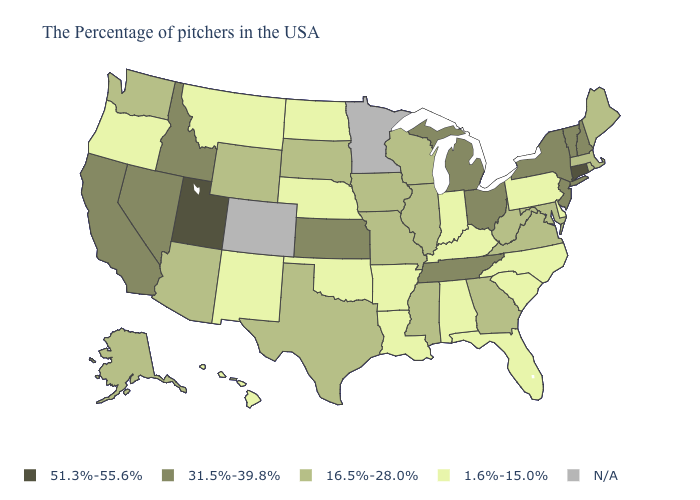Among the states that border Minnesota , which have the lowest value?
Give a very brief answer. North Dakota. Does the map have missing data?
Write a very short answer. Yes. What is the value of Connecticut?
Short answer required. 51.3%-55.6%. What is the value of Connecticut?
Keep it brief. 51.3%-55.6%. What is the value of Alabama?
Write a very short answer. 1.6%-15.0%. What is the value of Maryland?
Concise answer only. 16.5%-28.0%. Among the states that border Arkansas , which have the highest value?
Keep it brief. Tennessee. Name the states that have a value in the range 51.3%-55.6%?
Be succinct. Connecticut, Utah. What is the highest value in the USA?
Write a very short answer. 51.3%-55.6%. Does North Carolina have the lowest value in the USA?
Be succinct. Yes. What is the value of Maryland?
Give a very brief answer. 16.5%-28.0%. Which states have the lowest value in the Northeast?
Quick response, please. Pennsylvania. What is the value of Nebraska?
Concise answer only. 1.6%-15.0%. What is the value of Wisconsin?
Give a very brief answer. 16.5%-28.0%. 